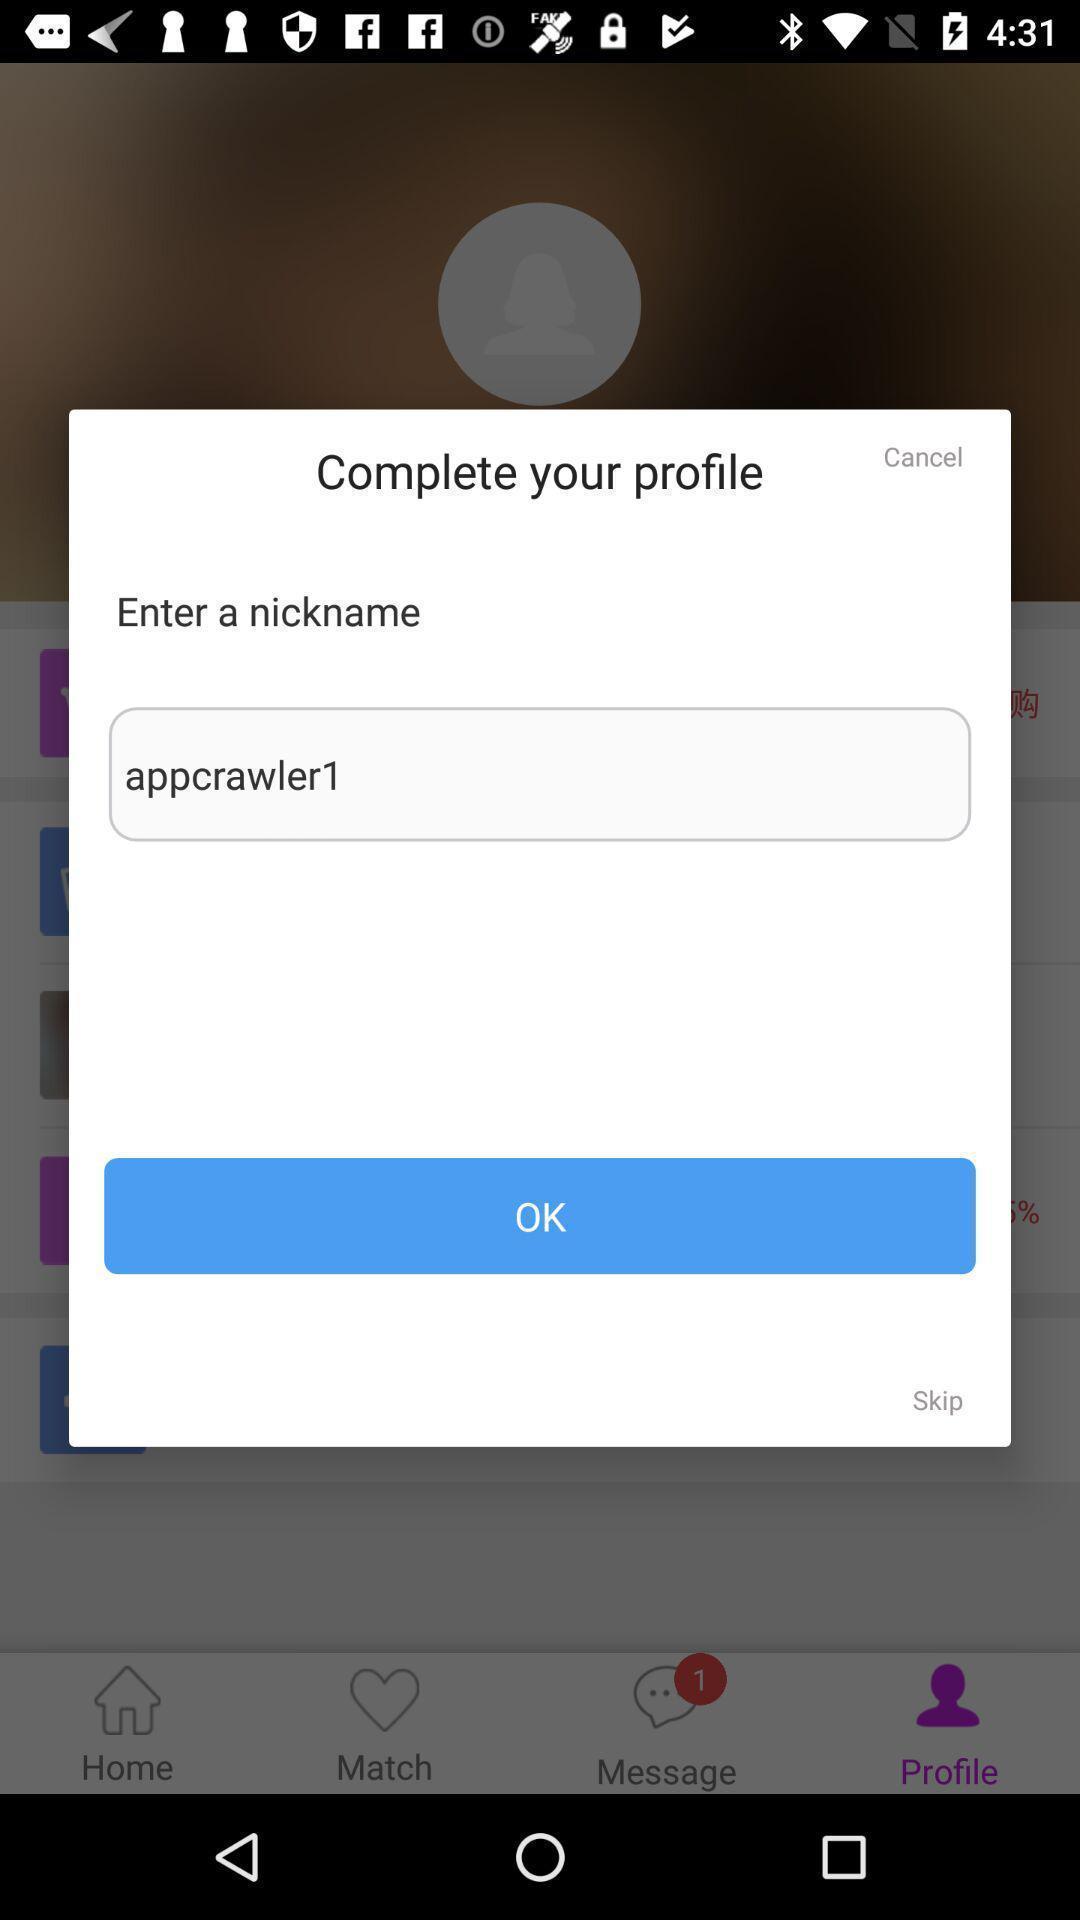Give me a narrative description of this picture. Popup to enter nickname for the social network app. 